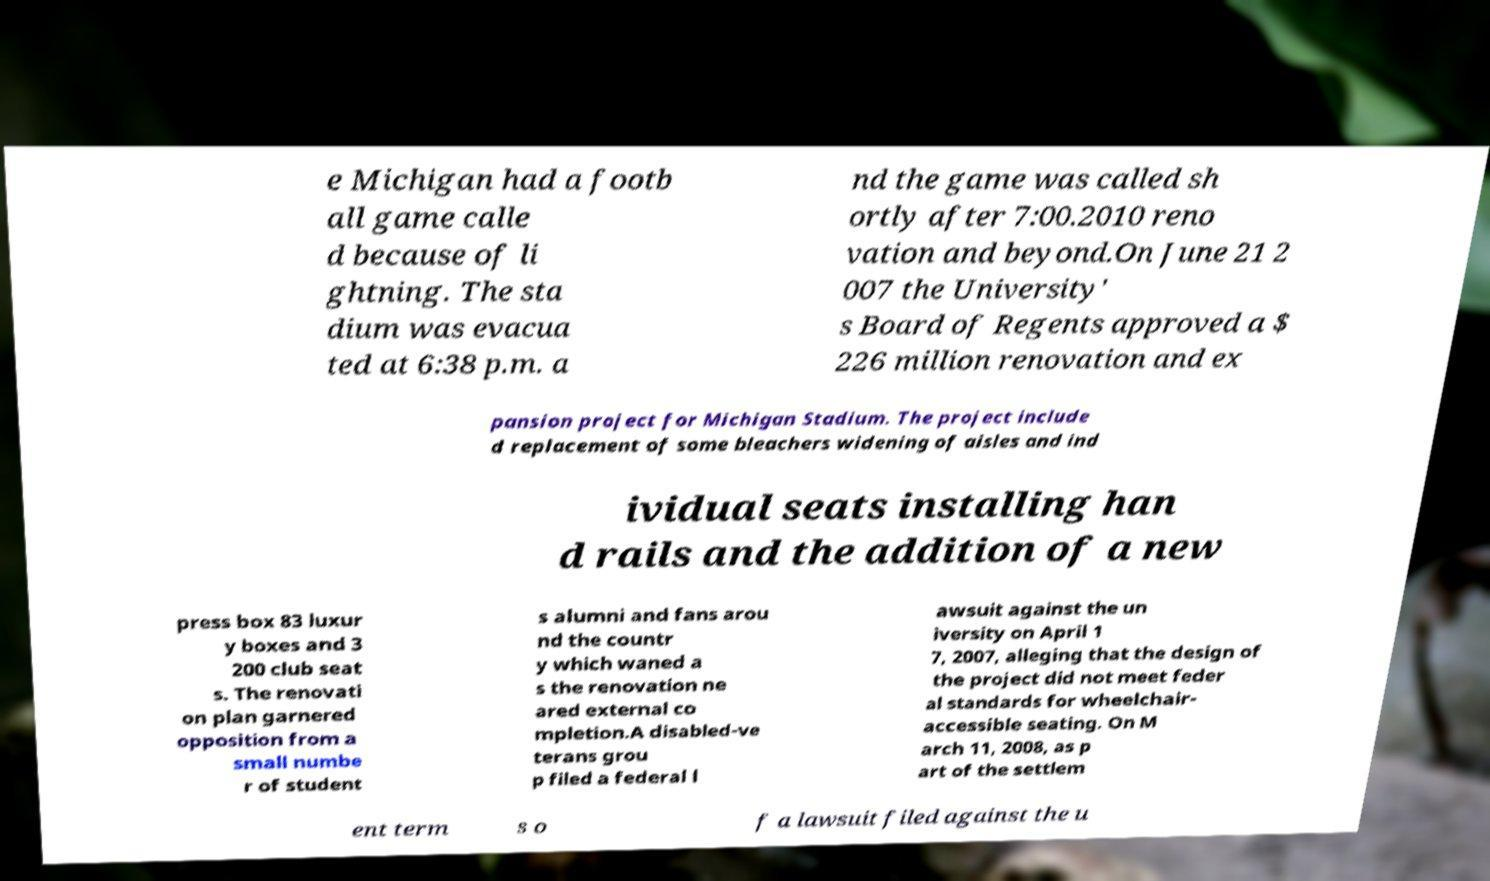For documentation purposes, I need the text within this image transcribed. Could you provide that? e Michigan had a footb all game calle d because of li ghtning. The sta dium was evacua ted at 6:38 p.m. a nd the game was called sh ortly after 7:00.2010 reno vation and beyond.On June 21 2 007 the University' s Board of Regents approved a $ 226 million renovation and ex pansion project for Michigan Stadium. The project include d replacement of some bleachers widening of aisles and ind ividual seats installing han d rails and the addition of a new press box 83 luxur y boxes and 3 200 club seat s. The renovati on plan garnered opposition from a small numbe r of student s alumni and fans arou nd the countr y which waned a s the renovation ne ared external co mpletion.A disabled-ve terans grou p filed a federal l awsuit against the un iversity on April 1 7, 2007, alleging that the design of the project did not meet feder al standards for wheelchair- accessible seating. On M arch 11, 2008, as p art of the settlem ent term s o f a lawsuit filed against the u 